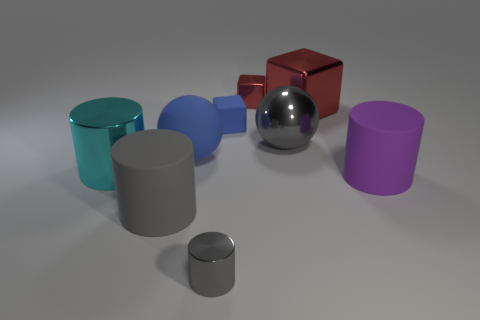Add 1 tiny blue things. How many objects exist? 10 Subtract all cylinders. How many objects are left? 5 Subtract 0 brown cylinders. How many objects are left? 9 Subtract all tiny gray matte cylinders. Subtract all cylinders. How many objects are left? 5 Add 7 big gray matte cylinders. How many big gray matte cylinders are left? 8 Add 3 big brown rubber blocks. How many big brown rubber blocks exist? 3 